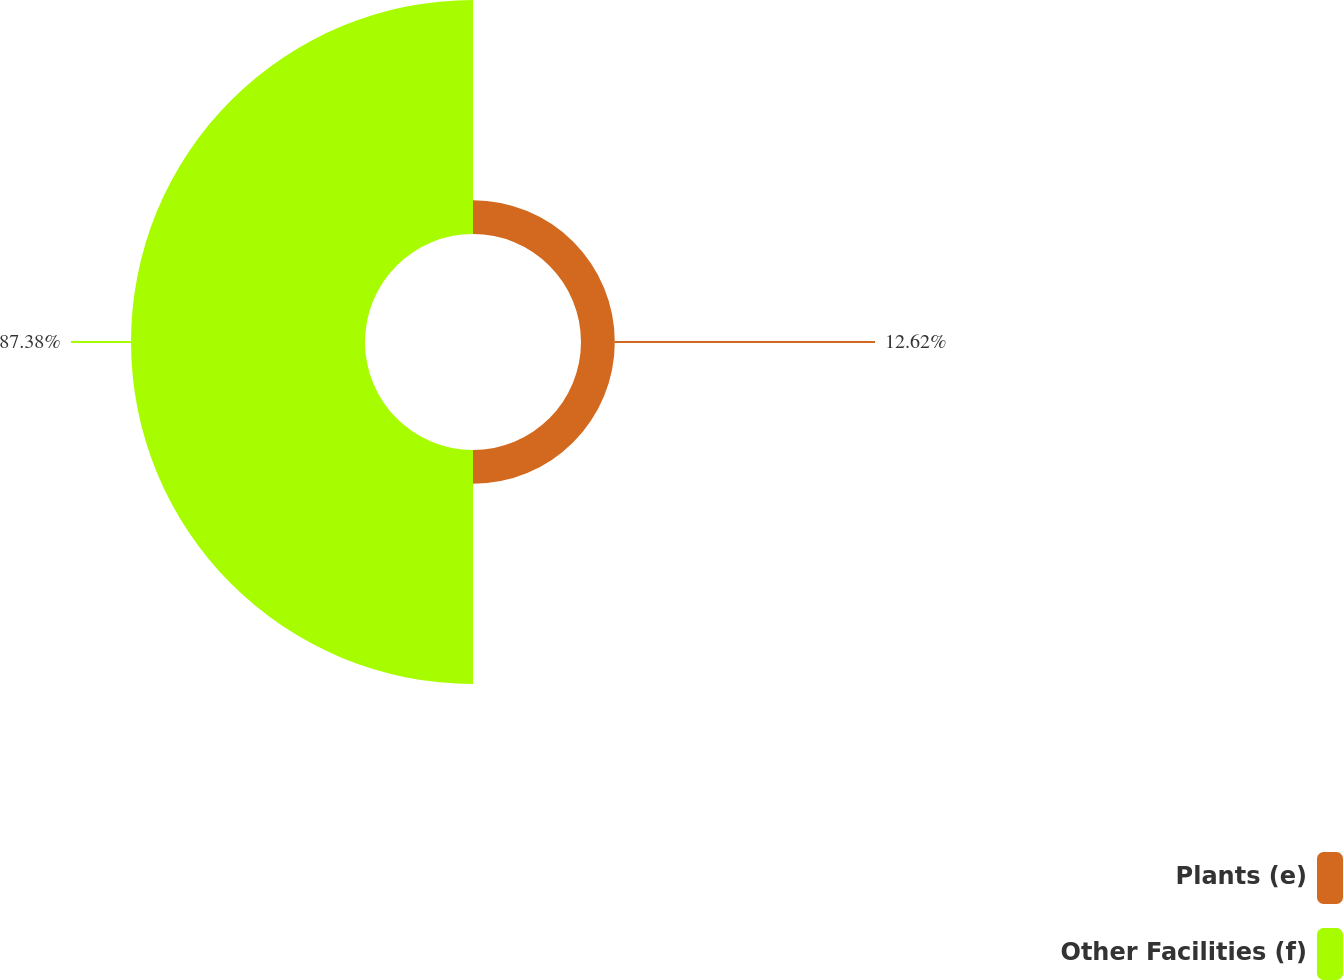Convert chart to OTSL. <chart><loc_0><loc_0><loc_500><loc_500><pie_chart><fcel>Plants (e)<fcel>Other Facilities (f)<nl><fcel>12.62%<fcel>87.38%<nl></chart> 